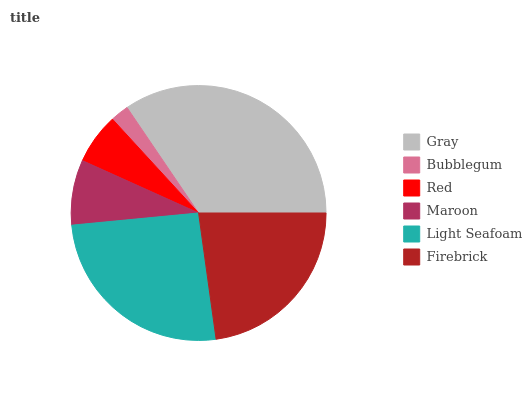Is Bubblegum the minimum?
Answer yes or no. Yes. Is Gray the maximum?
Answer yes or no. Yes. Is Red the minimum?
Answer yes or no. No. Is Red the maximum?
Answer yes or no. No. Is Red greater than Bubblegum?
Answer yes or no. Yes. Is Bubblegum less than Red?
Answer yes or no. Yes. Is Bubblegum greater than Red?
Answer yes or no. No. Is Red less than Bubblegum?
Answer yes or no. No. Is Firebrick the high median?
Answer yes or no. Yes. Is Maroon the low median?
Answer yes or no. Yes. Is Red the high median?
Answer yes or no. No. Is Gray the low median?
Answer yes or no. No. 